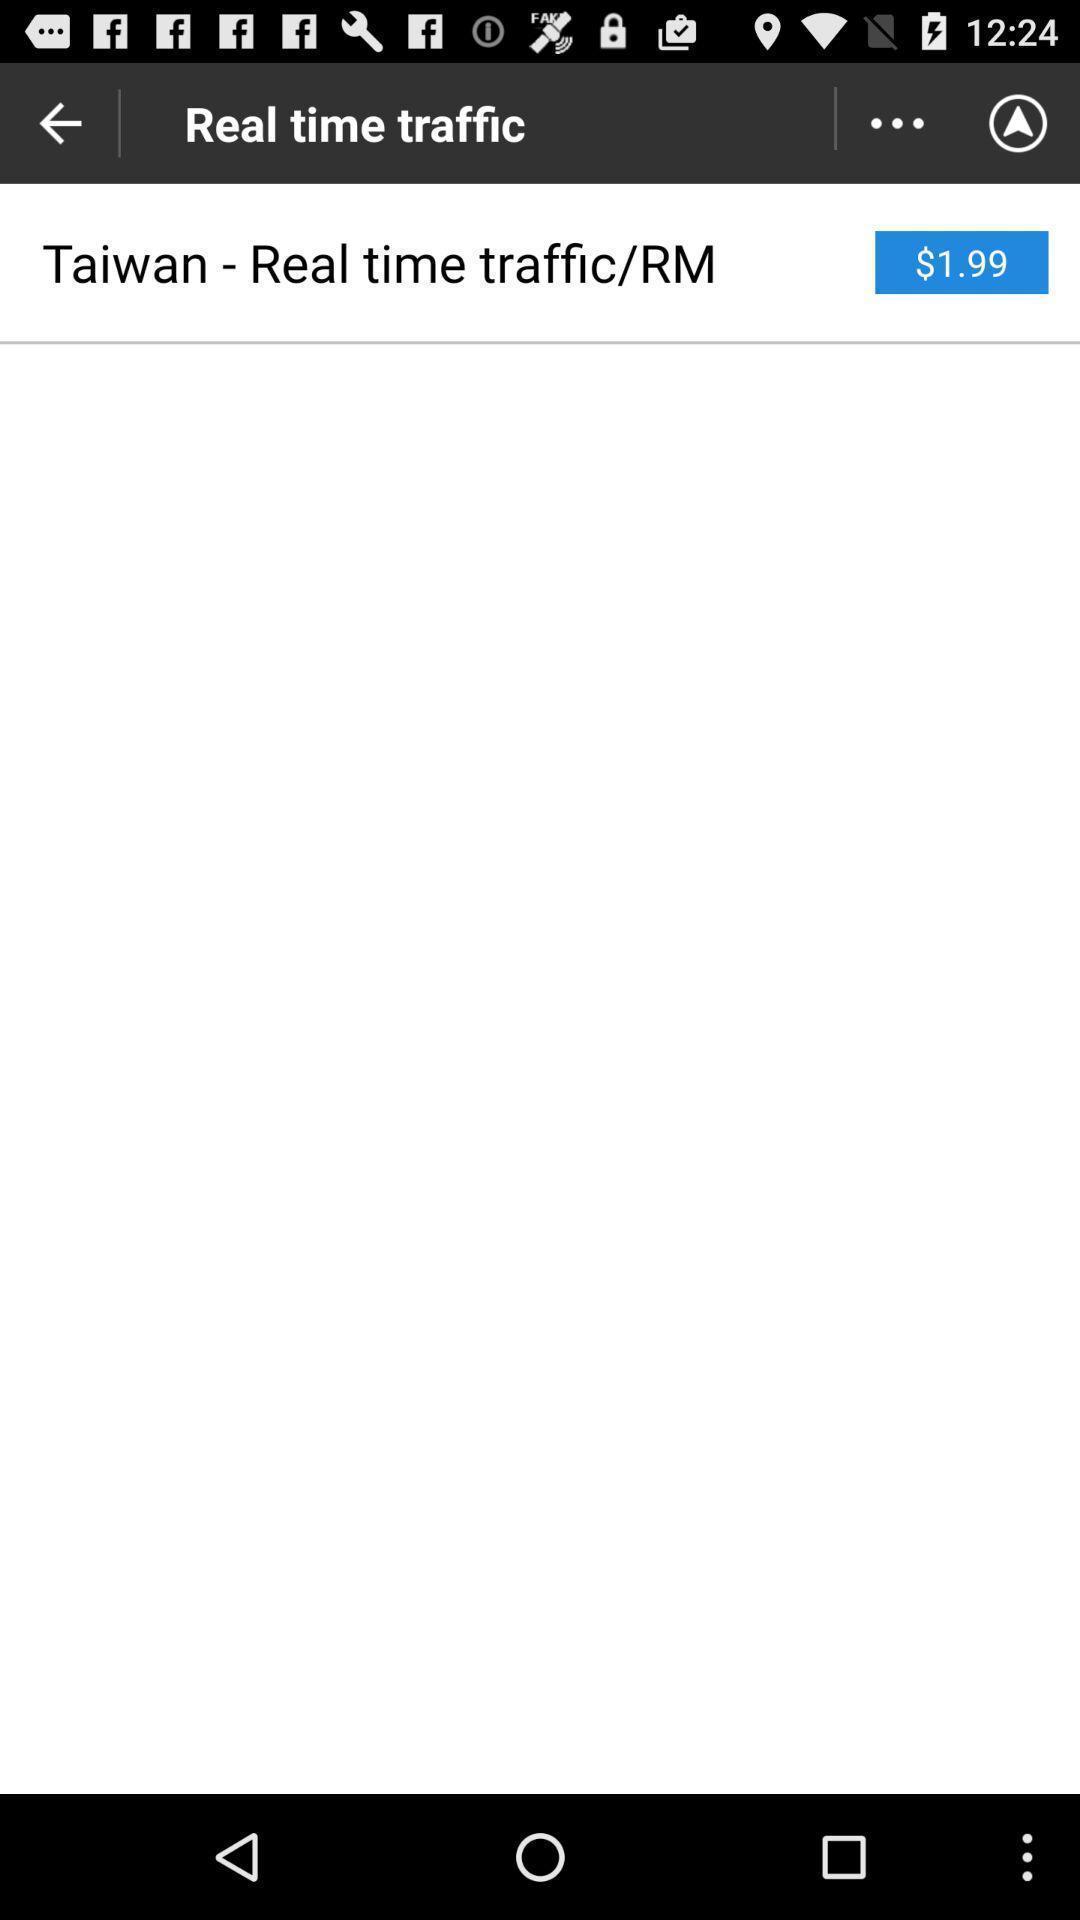What details can you identify in this image? Screen displaying the real time traffic page. 